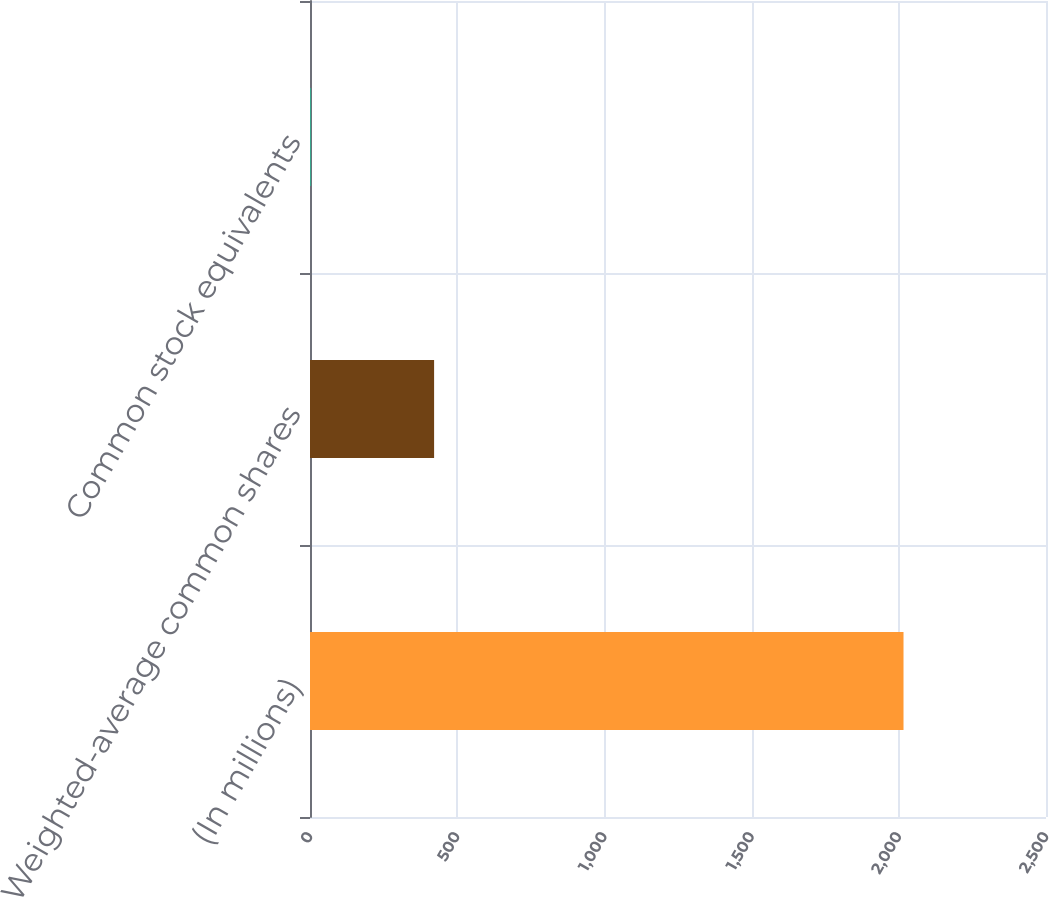<chart> <loc_0><loc_0><loc_500><loc_500><bar_chart><fcel>(In millions)<fcel>Weighted-average common shares<fcel>Common stock equivalents<nl><fcel>2016<fcel>421.54<fcel>3.6<nl></chart> 